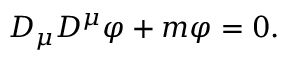Convert formula to latex. <formula><loc_0><loc_0><loc_500><loc_500>D _ { \mu } D ^ { \mu } \varphi + m \varphi = 0 .</formula> 